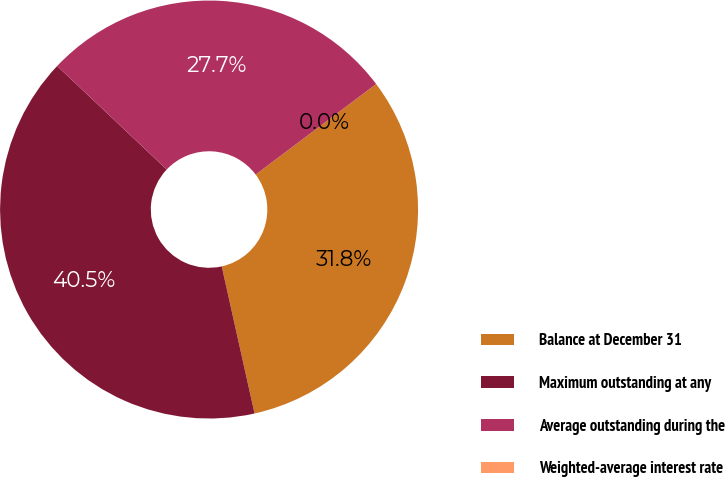Convert chart to OTSL. <chart><loc_0><loc_0><loc_500><loc_500><pie_chart><fcel>Balance at December 31<fcel>Maximum outstanding at any<fcel>Average outstanding during the<fcel>Weighted-average interest rate<nl><fcel>31.76%<fcel>40.54%<fcel>27.7%<fcel>0.0%<nl></chart> 